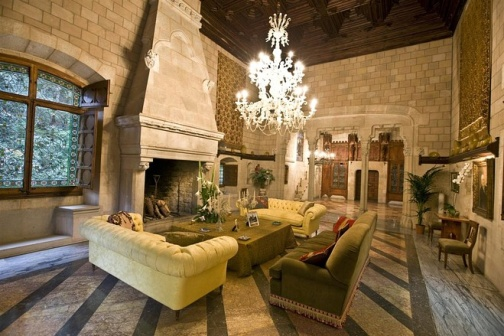Does this room seem to belong to a specific historical period? The living room exudes a classic, possibly Renaissance, ambiance with its high ceiling, chandelier, and grand stone fireplace. These elements, along with the use of rich materials and majestic furnishings, could suggest that the room's design takes inspiration from classical European architecture and interior design principles that were prevalent from the 14th to the 17th century. Can you tell me more about the furniture style? The furniture pieces are reminiscent of traditional styles, likely influenced by Baroque or Victorian-era designs. They are characterized by their substantial size, comfort, and the use of luxurious fabrics. The sofas have a robust and plush appearance with what appears to be velvet upholstery, and the red armchair adds a pop of color and grandeur that complements the overall aesthetic of the room. 